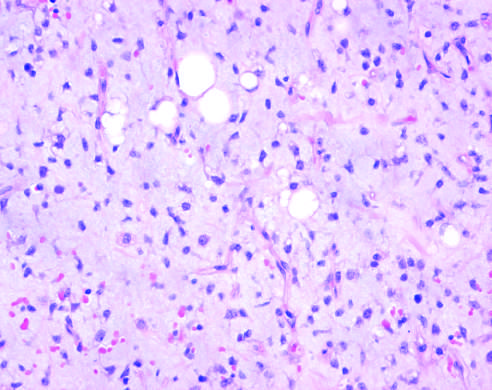where are scattered immature adipocytes and more primitive round-to-stellate cells?
Answer the question using a single word or phrase. Myxoid liposarcoma with abundant ground substance and a rich capillary network 